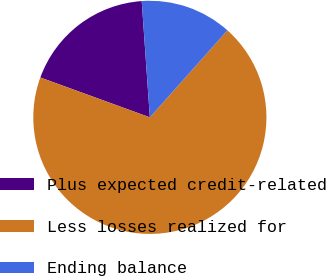Convert chart to OTSL. <chart><loc_0><loc_0><loc_500><loc_500><pie_chart><fcel>Plus expected credit-related<fcel>Less losses realized for<fcel>Ending balance<nl><fcel>18.33%<fcel>68.97%<fcel>12.7%<nl></chart> 